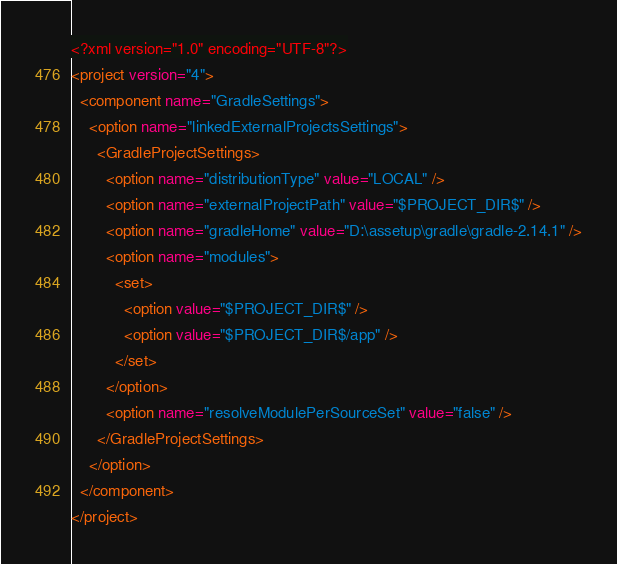<code> <loc_0><loc_0><loc_500><loc_500><_XML_><?xml version="1.0" encoding="UTF-8"?>
<project version="4">
  <component name="GradleSettings">
    <option name="linkedExternalProjectsSettings">
      <GradleProjectSettings>
        <option name="distributionType" value="LOCAL" />
        <option name="externalProjectPath" value="$PROJECT_DIR$" />
        <option name="gradleHome" value="D:\assetup\gradle\gradle-2.14.1" />
        <option name="modules">
          <set>
            <option value="$PROJECT_DIR$" />
            <option value="$PROJECT_DIR$/app" />
          </set>
        </option>
        <option name="resolveModulePerSourceSet" value="false" />
      </GradleProjectSettings>
    </option>
  </component>
</project></code> 